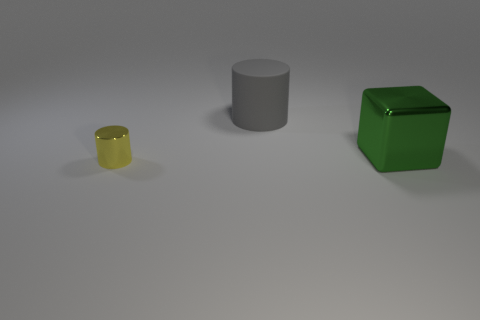How many other objects are there of the same size as the gray cylinder?
Offer a very short reply. 1. How many big green objects are there?
Offer a terse response. 1. Are there any other things that have the same shape as the gray rubber object?
Your answer should be very brief. Yes. Do the object in front of the green shiny cube and the cylinder behind the green metallic thing have the same material?
Your response must be concise. No. What is the material of the large cube?
Your answer should be very brief. Metal. What number of brown spheres are made of the same material as the tiny cylinder?
Ensure brevity in your answer.  0. How many matte objects are blocks or big green balls?
Keep it short and to the point. 0. Is the shape of the object on the left side of the large rubber cylinder the same as the big thing on the left side of the green cube?
Provide a succinct answer. Yes. What color is the object that is both in front of the big cylinder and behind the small yellow cylinder?
Offer a very short reply. Green. There is a cylinder that is behind the small yellow cylinder; does it have the same size as the metallic object behind the tiny yellow thing?
Give a very brief answer. Yes. 